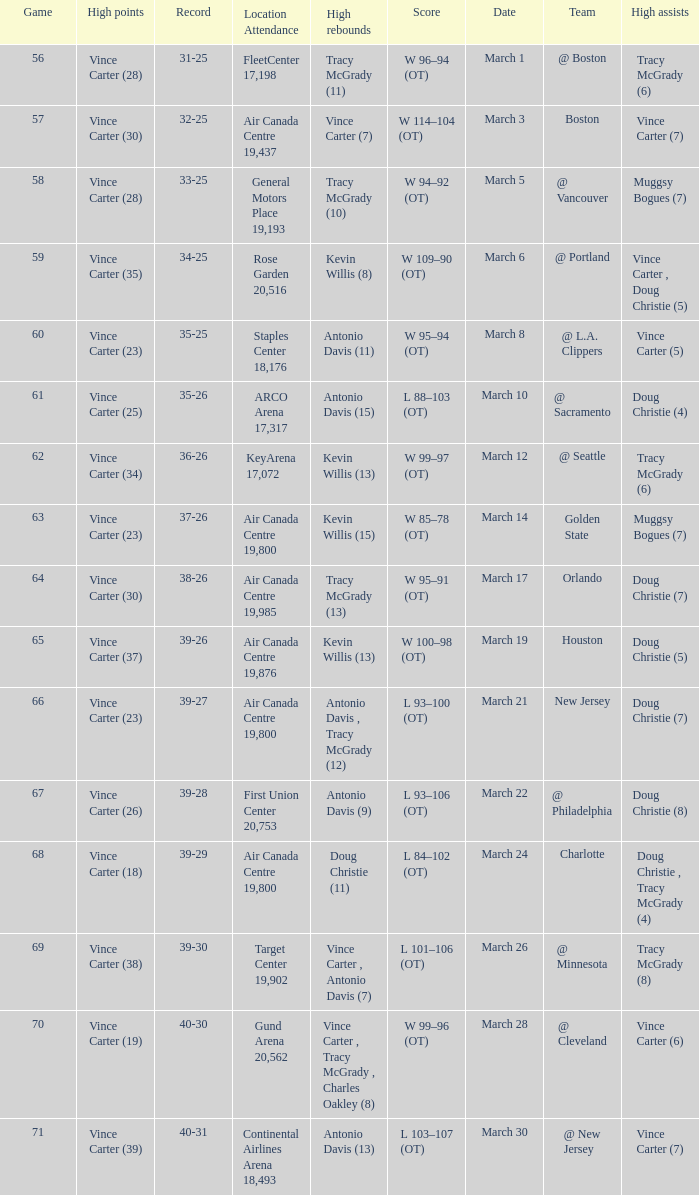Write the full table. {'header': ['Game', 'High points', 'Record', 'Location Attendance', 'High rebounds', 'Score', 'Date', 'Team', 'High assists'], 'rows': [['56', 'Vince Carter (28)', '31-25', 'FleetCenter 17,198', 'Tracy McGrady (11)', 'W 96–94 (OT)', 'March 1', '@ Boston', 'Tracy McGrady (6)'], ['57', 'Vince Carter (30)', '32-25', 'Air Canada Centre 19,437', 'Vince Carter (7)', 'W 114–104 (OT)', 'March 3', 'Boston', 'Vince Carter (7)'], ['58', 'Vince Carter (28)', '33-25', 'General Motors Place 19,193', 'Tracy McGrady (10)', 'W 94–92 (OT)', 'March 5', '@ Vancouver', 'Muggsy Bogues (7)'], ['59', 'Vince Carter (35)', '34-25', 'Rose Garden 20,516', 'Kevin Willis (8)', 'W 109–90 (OT)', 'March 6', '@ Portland', 'Vince Carter , Doug Christie (5)'], ['60', 'Vince Carter (23)', '35-25', 'Staples Center 18,176', 'Antonio Davis (11)', 'W 95–94 (OT)', 'March 8', '@ L.A. Clippers', 'Vince Carter (5)'], ['61', 'Vince Carter (25)', '35-26', 'ARCO Arena 17,317', 'Antonio Davis (15)', 'L 88–103 (OT)', 'March 10', '@ Sacramento', 'Doug Christie (4)'], ['62', 'Vince Carter (34)', '36-26', 'KeyArena 17,072', 'Kevin Willis (13)', 'W 99–97 (OT)', 'March 12', '@ Seattle', 'Tracy McGrady (6)'], ['63', 'Vince Carter (23)', '37-26', 'Air Canada Centre 19,800', 'Kevin Willis (15)', 'W 85–78 (OT)', 'March 14', 'Golden State', 'Muggsy Bogues (7)'], ['64', 'Vince Carter (30)', '38-26', 'Air Canada Centre 19,985', 'Tracy McGrady (13)', 'W 95–91 (OT)', 'March 17', 'Orlando', 'Doug Christie (7)'], ['65', 'Vince Carter (37)', '39-26', 'Air Canada Centre 19,876', 'Kevin Willis (13)', 'W 100–98 (OT)', 'March 19', 'Houston', 'Doug Christie (5)'], ['66', 'Vince Carter (23)', '39-27', 'Air Canada Centre 19,800', 'Antonio Davis , Tracy McGrady (12)', 'L 93–100 (OT)', 'March 21', 'New Jersey', 'Doug Christie (7)'], ['67', 'Vince Carter (26)', '39-28', 'First Union Center 20,753', 'Antonio Davis (9)', 'L 93–106 (OT)', 'March 22', '@ Philadelphia', 'Doug Christie (8)'], ['68', 'Vince Carter (18)', '39-29', 'Air Canada Centre 19,800', 'Doug Christie (11)', 'L 84–102 (OT)', 'March 24', 'Charlotte', 'Doug Christie , Tracy McGrady (4)'], ['69', 'Vince Carter (38)', '39-30', 'Target Center 19,902', 'Vince Carter , Antonio Davis (7)', 'L 101–106 (OT)', 'March 26', '@ Minnesota', 'Tracy McGrady (8)'], ['70', 'Vince Carter (19)', '40-30', 'Gund Arena 20,562', 'Vince Carter , Tracy McGrady , Charles Oakley (8)', 'W 99–96 (OT)', 'March 28', '@ Cleveland', 'Vince Carter (6)'], ['71', 'Vince Carter (39)', '40-31', 'Continental Airlines Arena 18,493', 'Antonio Davis (13)', 'L 103–107 (OT)', 'March 30', '@ New Jersey', 'Vince Carter (7)']]} Where did the team play and what was the attendance against new jersey? Air Canada Centre 19,800. 